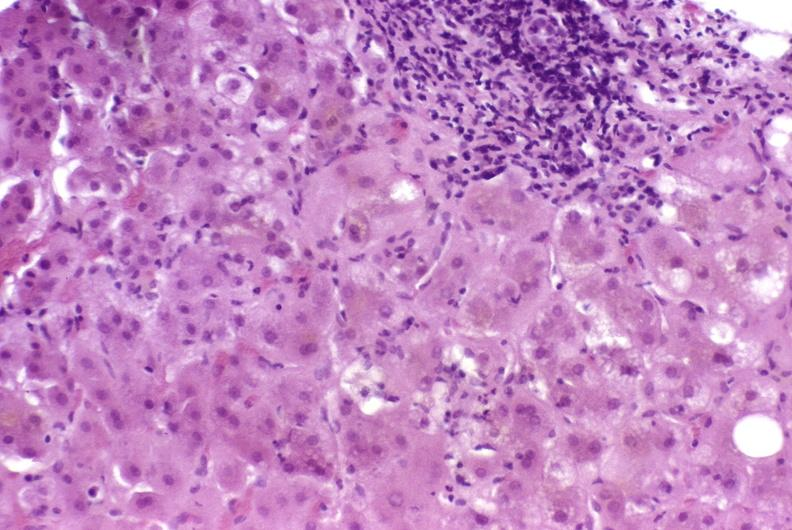what does this image show?
Answer the question using a single word or phrase. Autoimmune hepatitis 